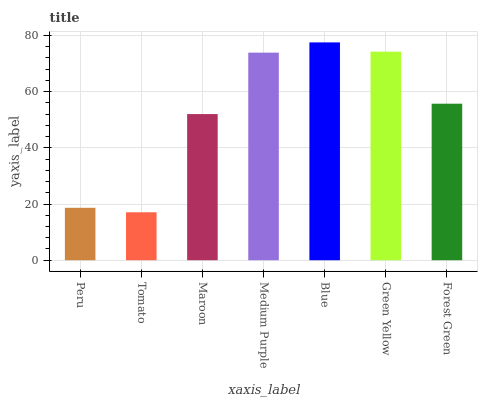Is Tomato the minimum?
Answer yes or no. Yes. Is Blue the maximum?
Answer yes or no. Yes. Is Maroon the minimum?
Answer yes or no. No. Is Maroon the maximum?
Answer yes or no. No. Is Maroon greater than Tomato?
Answer yes or no. Yes. Is Tomato less than Maroon?
Answer yes or no. Yes. Is Tomato greater than Maroon?
Answer yes or no. No. Is Maroon less than Tomato?
Answer yes or no. No. Is Forest Green the high median?
Answer yes or no. Yes. Is Forest Green the low median?
Answer yes or no. Yes. Is Peru the high median?
Answer yes or no. No. Is Blue the low median?
Answer yes or no. No. 